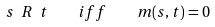Convert formula to latex. <formula><loc_0><loc_0><loc_500><loc_500>s \ R \ t \quad i f f \quad m ( s , t ) = 0</formula> 